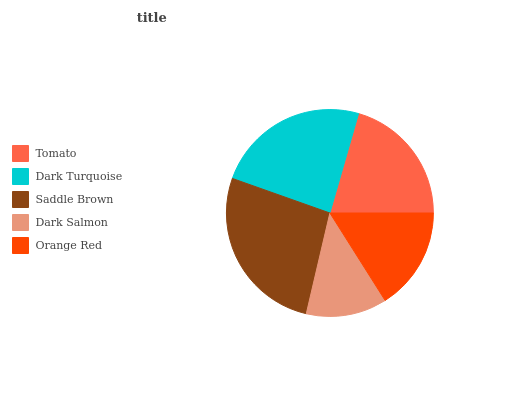Is Dark Salmon the minimum?
Answer yes or no. Yes. Is Saddle Brown the maximum?
Answer yes or no. Yes. Is Dark Turquoise the minimum?
Answer yes or no. No. Is Dark Turquoise the maximum?
Answer yes or no. No. Is Dark Turquoise greater than Tomato?
Answer yes or no. Yes. Is Tomato less than Dark Turquoise?
Answer yes or no. Yes. Is Tomato greater than Dark Turquoise?
Answer yes or no. No. Is Dark Turquoise less than Tomato?
Answer yes or no. No. Is Tomato the high median?
Answer yes or no. Yes. Is Tomato the low median?
Answer yes or no. Yes. Is Orange Red the high median?
Answer yes or no. No. Is Orange Red the low median?
Answer yes or no. No. 